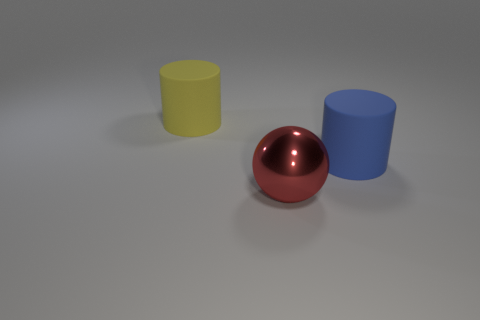Add 2 brown blocks. How many objects exist? 5 Subtract all green cylinders. Subtract all red spheres. How many cylinders are left? 2 Subtract all large blue things. Subtract all large matte blocks. How many objects are left? 2 Add 1 large red spheres. How many large red spheres are left? 2 Add 1 tiny yellow metallic things. How many tiny yellow metallic things exist? 1 Subtract 0 red cubes. How many objects are left? 3 Subtract all cylinders. How many objects are left? 1 